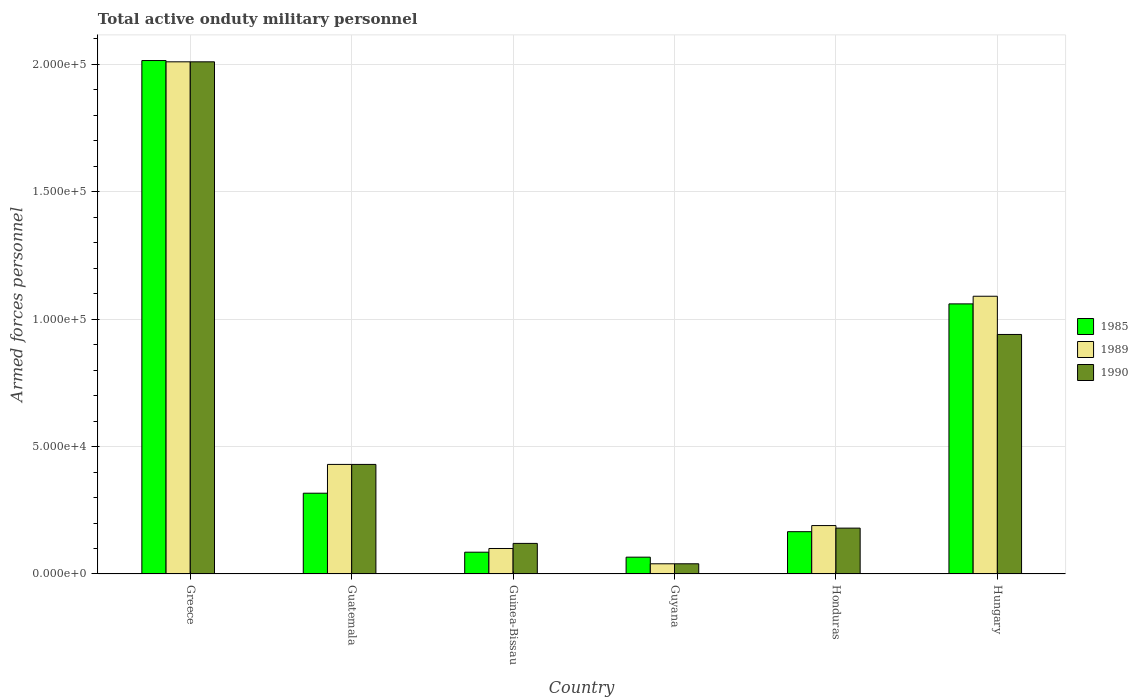How many different coloured bars are there?
Keep it short and to the point. 3. Are the number of bars per tick equal to the number of legend labels?
Offer a terse response. Yes. Are the number of bars on each tick of the X-axis equal?
Offer a very short reply. Yes. How many bars are there on the 6th tick from the left?
Your answer should be very brief. 3. What is the label of the 4th group of bars from the left?
Offer a very short reply. Guyana. In how many cases, is the number of bars for a given country not equal to the number of legend labels?
Make the answer very short. 0. What is the number of armed forces personnel in 1990 in Guatemala?
Ensure brevity in your answer.  4.30e+04. Across all countries, what is the maximum number of armed forces personnel in 1985?
Offer a very short reply. 2.02e+05. Across all countries, what is the minimum number of armed forces personnel in 1985?
Keep it short and to the point. 6600. In which country was the number of armed forces personnel in 1989 maximum?
Provide a short and direct response. Greece. In which country was the number of armed forces personnel in 1989 minimum?
Offer a very short reply. Guyana. What is the total number of armed forces personnel in 1989 in the graph?
Offer a terse response. 3.86e+05. What is the difference between the number of armed forces personnel in 1985 in Guyana and that in Hungary?
Your answer should be very brief. -9.94e+04. What is the difference between the number of armed forces personnel in 1989 in Hungary and the number of armed forces personnel in 1990 in Guinea-Bissau?
Your answer should be very brief. 9.70e+04. What is the average number of armed forces personnel in 1990 per country?
Make the answer very short. 6.20e+04. What is the difference between the number of armed forces personnel of/in 1985 and number of armed forces personnel of/in 1990 in Honduras?
Offer a very short reply. -1400. In how many countries, is the number of armed forces personnel in 1989 greater than 140000?
Your response must be concise. 1. What is the ratio of the number of armed forces personnel in 1989 in Guinea-Bissau to that in Hungary?
Offer a terse response. 0.09. What is the difference between the highest and the second highest number of armed forces personnel in 1990?
Offer a terse response. 1.07e+05. What is the difference between the highest and the lowest number of armed forces personnel in 1989?
Your answer should be compact. 1.97e+05. In how many countries, is the number of armed forces personnel in 1990 greater than the average number of armed forces personnel in 1990 taken over all countries?
Your response must be concise. 2. Is the sum of the number of armed forces personnel in 1989 in Greece and Honduras greater than the maximum number of armed forces personnel in 1990 across all countries?
Ensure brevity in your answer.  Yes. What does the 3rd bar from the left in Guyana represents?
Offer a terse response. 1990. How many bars are there?
Your response must be concise. 18. Are all the bars in the graph horizontal?
Provide a succinct answer. No. How many countries are there in the graph?
Give a very brief answer. 6. Does the graph contain any zero values?
Your response must be concise. No. Does the graph contain grids?
Ensure brevity in your answer.  Yes. Where does the legend appear in the graph?
Give a very brief answer. Center right. How many legend labels are there?
Ensure brevity in your answer.  3. How are the legend labels stacked?
Keep it short and to the point. Vertical. What is the title of the graph?
Your answer should be very brief. Total active onduty military personnel. Does "1997" appear as one of the legend labels in the graph?
Provide a succinct answer. No. What is the label or title of the X-axis?
Give a very brief answer. Country. What is the label or title of the Y-axis?
Offer a very short reply. Armed forces personnel. What is the Armed forces personnel of 1985 in Greece?
Ensure brevity in your answer.  2.02e+05. What is the Armed forces personnel in 1989 in Greece?
Ensure brevity in your answer.  2.01e+05. What is the Armed forces personnel of 1990 in Greece?
Offer a very short reply. 2.01e+05. What is the Armed forces personnel in 1985 in Guatemala?
Your answer should be very brief. 3.17e+04. What is the Armed forces personnel in 1989 in Guatemala?
Provide a succinct answer. 4.30e+04. What is the Armed forces personnel in 1990 in Guatemala?
Offer a terse response. 4.30e+04. What is the Armed forces personnel of 1985 in Guinea-Bissau?
Ensure brevity in your answer.  8550. What is the Armed forces personnel of 1989 in Guinea-Bissau?
Keep it short and to the point. 10000. What is the Armed forces personnel in 1990 in Guinea-Bissau?
Make the answer very short. 1.20e+04. What is the Armed forces personnel of 1985 in Guyana?
Offer a very short reply. 6600. What is the Armed forces personnel in 1989 in Guyana?
Your answer should be compact. 4000. What is the Armed forces personnel of 1990 in Guyana?
Your response must be concise. 4000. What is the Armed forces personnel of 1985 in Honduras?
Your response must be concise. 1.66e+04. What is the Armed forces personnel of 1989 in Honduras?
Make the answer very short. 1.90e+04. What is the Armed forces personnel of 1990 in Honduras?
Give a very brief answer. 1.80e+04. What is the Armed forces personnel in 1985 in Hungary?
Ensure brevity in your answer.  1.06e+05. What is the Armed forces personnel in 1989 in Hungary?
Provide a succinct answer. 1.09e+05. What is the Armed forces personnel of 1990 in Hungary?
Make the answer very short. 9.40e+04. Across all countries, what is the maximum Armed forces personnel in 1985?
Ensure brevity in your answer.  2.02e+05. Across all countries, what is the maximum Armed forces personnel in 1989?
Offer a very short reply. 2.01e+05. Across all countries, what is the maximum Armed forces personnel of 1990?
Offer a terse response. 2.01e+05. Across all countries, what is the minimum Armed forces personnel in 1985?
Provide a short and direct response. 6600. Across all countries, what is the minimum Armed forces personnel of 1989?
Your response must be concise. 4000. Across all countries, what is the minimum Armed forces personnel of 1990?
Provide a succinct answer. 4000. What is the total Armed forces personnel of 1985 in the graph?
Offer a terse response. 3.71e+05. What is the total Armed forces personnel of 1989 in the graph?
Your answer should be very brief. 3.86e+05. What is the total Armed forces personnel in 1990 in the graph?
Give a very brief answer. 3.72e+05. What is the difference between the Armed forces personnel in 1985 in Greece and that in Guatemala?
Provide a succinct answer. 1.70e+05. What is the difference between the Armed forces personnel in 1989 in Greece and that in Guatemala?
Your response must be concise. 1.58e+05. What is the difference between the Armed forces personnel in 1990 in Greece and that in Guatemala?
Your answer should be very brief. 1.58e+05. What is the difference between the Armed forces personnel in 1985 in Greece and that in Guinea-Bissau?
Provide a short and direct response. 1.93e+05. What is the difference between the Armed forces personnel of 1989 in Greece and that in Guinea-Bissau?
Keep it short and to the point. 1.91e+05. What is the difference between the Armed forces personnel of 1990 in Greece and that in Guinea-Bissau?
Your answer should be compact. 1.89e+05. What is the difference between the Armed forces personnel in 1985 in Greece and that in Guyana?
Offer a terse response. 1.95e+05. What is the difference between the Armed forces personnel of 1989 in Greece and that in Guyana?
Make the answer very short. 1.97e+05. What is the difference between the Armed forces personnel of 1990 in Greece and that in Guyana?
Your response must be concise. 1.97e+05. What is the difference between the Armed forces personnel of 1985 in Greece and that in Honduras?
Your answer should be compact. 1.85e+05. What is the difference between the Armed forces personnel in 1989 in Greece and that in Honduras?
Offer a terse response. 1.82e+05. What is the difference between the Armed forces personnel of 1990 in Greece and that in Honduras?
Provide a succinct answer. 1.83e+05. What is the difference between the Armed forces personnel in 1985 in Greece and that in Hungary?
Your answer should be very brief. 9.55e+04. What is the difference between the Armed forces personnel of 1989 in Greece and that in Hungary?
Ensure brevity in your answer.  9.20e+04. What is the difference between the Armed forces personnel in 1990 in Greece and that in Hungary?
Your response must be concise. 1.07e+05. What is the difference between the Armed forces personnel of 1985 in Guatemala and that in Guinea-Bissau?
Provide a short and direct response. 2.32e+04. What is the difference between the Armed forces personnel in 1989 in Guatemala and that in Guinea-Bissau?
Offer a terse response. 3.30e+04. What is the difference between the Armed forces personnel in 1990 in Guatemala and that in Guinea-Bissau?
Make the answer very short. 3.10e+04. What is the difference between the Armed forces personnel of 1985 in Guatemala and that in Guyana?
Offer a terse response. 2.51e+04. What is the difference between the Armed forces personnel of 1989 in Guatemala and that in Guyana?
Keep it short and to the point. 3.90e+04. What is the difference between the Armed forces personnel of 1990 in Guatemala and that in Guyana?
Your answer should be very brief. 3.90e+04. What is the difference between the Armed forces personnel of 1985 in Guatemala and that in Honduras?
Give a very brief answer. 1.51e+04. What is the difference between the Armed forces personnel of 1989 in Guatemala and that in Honduras?
Your answer should be compact. 2.40e+04. What is the difference between the Armed forces personnel of 1990 in Guatemala and that in Honduras?
Your response must be concise. 2.50e+04. What is the difference between the Armed forces personnel of 1985 in Guatemala and that in Hungary?
Provide a succinct answer. -7.43e+04. What is the difference between the Armed forces personnel of 1989 in Guatemala and that in Hungary?
Give a very brief answer. -6.60e+04. What is the difference between the Armed forces personnel in 1990 in Guatemala and that in Hungary?
Your answer should be compact. -5.10e+04. What is the difference between the Armed forces personnel in 1985 in Guinea-Bissau and that in Guyana?
Keep it short and to the point. 1950. What is the difference between the Armed forces personnel in 1989 in Guinea-Bissau and that in Guyana?
Keep it short and to the point. 6000. What is the difference between the Armed forces personnel of 1990 in Guinea-Bissau and that in Guyana?
Keep it short and to the point. 8000. What is the difference between the Armed forces personnel of 1985 in Guinea-Bissau and that in Honduras?
Keep it short and to the point. -8050. What is the difference between the Armed forces personnel in 1989 in Guinea-Bissau and that in Honduras?
Give a very brief answer. -9000. What is the difference between the Armed forces personnel of 1990 in Guinea-Bissau and that in Honduras?
Your response must be concise. -6000. What is the difference between the Armed forces personnel in 1985 in Guinea-Bissau and that in Hungary?
Your answer should be compact. -9.74e+04. What is the difference between the Armed forces personnel in 1989 in Guinea-Bissau and that in Hungary?
Your answer should be compact. -9.90e+04. What is the difference between the Armed forces personnel in 1990 in Guinea-Bissau and that in Hungary?
Keep it short and to the point. -8.20e+04. What is the difference between the Armed forces personnel in 1989 in Guyana and that in Honduras?
Keep it short and to the point. -1.50e+04. What is the difference between the Armed forces personnel of 1990 in Guyana and that in Honduras?
Offer a terse response. -1.40e+04. What is the difference between the Armed forces personnel of 1985 in Guyana and that in Hungary?
Offer a terse response. -9.94e+04. What is the difference between the Armed forces personnel in 1989 in Guyana and that in Hungary?
Offer a very short reply. -1.05e+05. What is the difference between the Armed forces personnel in 1990 in Guyana and that in Hungary?
Your response must be concise. -9.00e+04. What is the difference between the Armed forces personnel in 1985 in Honduras and that in Hungary?
Provide a succinct answer. -8.94e+04. What is the difference between the Armed forces personnel in 1989 in Honduras and that in Hungary?
Your answer should be very brief. -9.00e+04. What is the difference between the Armed forces personnel in 1990 in Honduras and that in Hungary?
Keep it short and to the point. -7.60e+04. What is the difference between the Armed forces personnel of 1985 in Greece and the Armed forces personnel of 1989 in Guatemala?
Offer a terse response. 1.58e+05. What is the difference between the Armed forces personnel of 1985 in Greece and the Armed forces personnel of 1990 in Guatemala?
Keep it short and to the point. 1.58e+05. What is the difference between the Armed forces personnel in 1989 in Greece and the Armed forces personnel in 1990 in Guatemala?
Offer a terse response. 1.58e+05. What is the difference between the Armed forces personnel of 1985 in Greece and the Armed forces personnel of 1989 in Guinea-Bissau?
Your response must be concise. 1.92e+05. What is the difference between the Armed forces personnel of 1985 in Greece and the Armed forces personnel of 1990 in Guinea-Bissau?
Offer a very short reply. 1.90e+05. What is the difference between the Armed forces personnel of 1989 in Greece and the Armed forces personnel of 1990 in Guinea-Bissau?
Offer a terse response. 1.89e+05. What is the difference between the Armed forces personnel of 1985 in Greece and the Armed forces personnel of 1989 in Guyana?
Your response must be concise. 1.98e+05. What is the difference between the Armed forces personnel of 1985 in Greece and the Armed forces personnel of 1990 in Guyana?
Offer a very short reply. 1.98e+05. What is the difference between the Armed forces personnel of 1989 in Greece and the Armed forces personnel of 1990 in Guyana?
Offer a very short reply. 1.97e+05. What is the difference between the Armed forces personnel of 1985 in Greece and the Armed forces personnel of 1989 in Honduras?
Offer a very short reply. 1.82e+05. What is the difference between the Armed forces personnel of 1985 in Greece and the Armed forces personnel of 1990 in Honduras?
Your answer should be very brief. 1.84e+05. What is the difference between the Armed forces personnel in 1989 in Greece and the Armed forces personnel in 1990 in Honduras?
Provide a short and direct response. 1.83e+05. What is the difference between the Armed forces personnel in 1985 in Greece and the Armed forces personnel in 1989 in Hungary?
Ensure brevity in your answer.  9.25e+04. What is the difference between the Armed forces personnel of 1985 in Greece and the Armed forces personnel of 1990 in Hungary?
Provide a short and direct response. 1.08e+05. What is the difference between the Armed forces personnel in 1989 in Greece and the Armed forces personnel in 1990 in Hungary?
Offer a terse response. 1.07e+05. What is the difference between the Armed forces personnel of 1985 in Guatemala and the Armed forces personnel of 1989 in Guinea-Bissau?
Keep it short and to the point. 2.17e+04. What is the difference between the Armed forces personnel in 1985 in Guatemala and the Armed forces personnel in 1990 in Guinea-Bissau?
Make the answer very short. 1.97e+04. What is the difference between the Armed forces personnel in 1989 in Guatemala and the Armed forces personnel in 1990 in Guinea-Bissau?
Provide a succinct answer. 3.10e+04. What is the difference between the Armed forces personnel of 1985 in Guatemala and the Armed forces personnel of 1989 in Guyana?
Provide a succinct answer. 2.77e+04. What is the difference between the Armed forces personnel of 1985 in Guatemala and the Armed forces personnel of 1990 in Guyana?
Make the answer very short. 2.77e+04. What is the difference between the Armed forces personnel in 1989 in Guatemala and the Armed forces personnel in 1990 in Guyana?
Your answer should be compact. 3.90e+04. What is the difference between the Armed forces personnel in 1985 in Guatemala and the Armed forces personnel in 1989 in Honduras?
Provide a succinct answer. 1.27e+04. What is the difference between the Armed forces personnel in 1985 in Guatemala and the Armed forces personnel in 1990 in Honduras?
Provide a succinct answer. 1.37e+04. What is the difference between the Armed forces personnel of 1989 in Guatemala and the Armed forces personnel of 1990 in Honduras?
Offer a terse response. 2.50e+04. What is the difference between the Armed forces personnel of 1985 in Guatemala and the Armed forces personnel of 1989 in Hungary?
Offer a very short reply. -7.73e+04. What is the difference between the Armed forces personnel of 1985 in Guatemala and the Armed forces personnel of 1990 in Hungary?
Provide a short and direct response. -6.23e+04. What is the difference between the Armed forces personnel in 1989 in Guatemala and the Armed forces personnel in 1990 in Hungary?
Offer a terse response. -5.10e+04. What is the difference between the Armed forces personnel of 1985 in Guinea-Bissau and the Armed forces personnel of 1989 in Guyana?
Provide a short and direct response. 4550. What is the difference between the Armed forces personnel of 1985 in Guinea-Bissau and the Armed forces personnel of 1990 in Guyana?
Your response must be concise. 4550. What is the difference between the Armed forces personnel in 1989 in Guinea-Bissau and the Armed forces personnel in 1990 in Guyana?
Your answer should be compact. 6000. What is the difference between the Armed forces personnel in 1985 in Guinea-Bissau and the Armed forces personnel in 1989 in Honduras?
Provide a short and direct response. -1.04e+04. What is the difference between the Armed forces personnel of 1985 in Guinea-Bissau and the Armed forces personnel of 1990 in Honduras?
Your answer should be very brief. -9450. What is the difference between the Armed forces personnel in 1989 in Guinea-Bissau and the Armed forces personnel in 1990 in Honduras?
Your response must be concise. -8000. What is the difference between the Armed forces personnel in 1985 in Guinea-Bissau and the Armed forces personnel in 1989 in Hungary?
Provide a succinct answer. -1.00e+05. What is the difference between the Armed forces personnel in 1985 in Guinea-Bissau and the Armed forces personnel in 1990 in Hungary?
Your answer should be compact. -8.54e+04. What is the difference between the Armed forces personnel of 1989 in Guinea-Bissau and the Armed forces personnel of 1990 in Hungary?
Keep it short and to the point. -8.40e+04. What is the difference between the Armed forces personnel in 1985 in Guyana and the Armed forces personnel in 1989 in Honduras?
Make the answer very short. -1.24e+04. What is the difference between the Armed forces personnel of 1985 in Guyana and the Armed forces personnel of 1990 in Honduras?
Ensure brevity in your answer.  -1.14e+04. What is the difference between the Armed forces personnel of 1989 in Guyana and the Armed forces personnel of 1990 in Honduras?
Your answer should be compact. -1.40e+04. What is the difference between the Armed forces personnel in 1985 in Guyana and the Armed forces personnel in 1989 in Hungary?
Provide a short and direct response. -1.02e+05. What is the difference between the Armed forces personnel of 1985 in Guyana and the Armed forces personnel of 1990 in Hungary?
Your answer should be very brief. -8.74e+04. What is the difference between the Armed forces personnel of 1989 in Guyana and the Armed forces personnel of 1990 in Hungary?
Make the answer very short. -9.00e+04. What is the difference between the Armed forces personnel in 1985 in Honduras and the Armed forces personnel in 1989 in Hungary?
Ensure brevity in your answer.  -9.24e+04. What is the difference between the Armed forces personnel in 1985 in Honduras and the Armed forces personnel in 1990 in Hungary?
Ensure brevity in your answer.  -7.74e+04. What is the difference between the Armed forces personnel of 1989 in Honduras and the Armed forces personnel of 1990 in Hungary?
Offer a very short reply. -7.50e+04. What is the average Armed forces personnel of 1985 per country?
Offer a terse response. 6.18e+04. What is the average Armed forces personnel in 1989 per country?
Your response must be concise. 6.43e+04. What is the average Armed forces personnel in 1990 per country?
Make the answer very short. 6.20e+04. What is the difference between the Armed forces personnel of 1985 and Armed forces personnel of 1989 in Greece?
Give a very brief answer. 500. What is the difference between the Armed forces personnel in 1985 and Armed forces personnel in 1990 in Greece?
Your response must be concise. 500. What is the difference between the Armed forces personnel in 1989 and Armed forces personnel in 1990 in Greece?
Keep it short and to the point. 0. What is the difference between the Armed forces personnel of 1985 and Armed forces personnel of 1989 in Guatemala?
Your response must be concise. -1.13e+04. What is the difference between the Armed forces personnel in 1985 and Armed forces personnel in 1990 in Guatemala?
Give a very brief answer. -1.13e+04. What is the difference between the Armed forces personnel in 1989 and Armed forces personnel in 1990 in Guatemala?
Ensure brevity in your answer.  0. What is the difference between the Armed forces personnel in 1985 and Armed forces personnel in 1989 in Guinea-Bissau?
Ensure brevity in your answer.  -1450. What is the difference between the Armed forces personnel of 1985 and Armed forces personnel of 1990 in Guinea-Bissau?
Keep it short and to the point. -3450. What is the difference between the Armed forces personnel of 1989 and Armed forces personnel of 1990 in Guinea-Bissau?
Keep it short and to the point. -2000. What is the difference between the Armed forces personnel in 1985 and Armed forces personnel in 1989 in Guyana?
Keep it short and to the point. 2600. What is the difference between the Armed forces personnel in 1985 and Armed forces personnel in 1990 in Guyana?
Ensure brevity in your answer.  2600. What is the difference between the Armed forces personnel in 1989 and Armed forces personnel in 1990 in Guyana?
Make the answer very short. 0. What is the difference between the Armed forces personnel in 1985 and Armed forces personnel in 1989 in Honduras?
Make the answer very short. -2400. What is the difference between the Armed forces personnel in 1985 and Armed forces personnel in 1990 in Honduras?
Make the answer very short. -1400. What is the difference between the Armed forces personnel in 1989 and Armed forces personnel in 1990 in Honduras?
Provide a short and direct response. 1000. What is the difference between the Armed forces personnel in 1985 and Armed forces personnel in 1989 in Hungary?
Your response must be concise. -3000. What is the difference between the Armed forces personnel of 1985 and Armed forces personnel of 1990 in Hungary?
Make the answer very short. 1.20e+04. What is the difference between the Armed forces personnel of 1989 and Armed forces personnel of 1990 in Hungary?
Your answer should be very brief. 1.50e+04. What is the ratio of the Armed forces personnel in 1985 in Greece to that in Guatemala?
Provide a short and direct response. 6.36. What is the ratio of the Armed forces personnel in 1989 in Greece to that in Guatemala?
Ensure brevity in your answer.  4.67. What is the ratio of the Armed forces personnel in 1990 in Greece to that in Guatemala?
Your answer should be very brief. 4.67. What is the ratio of the Armed forces personnel in 1985 in Greece to that in Guinea-Bissau?
Make the answer very short. 23.57. What is the ratio of the Armed forces personnel in 1989 in Greece to that in Guinea-Bissau?
Keep it short and to the point. 20.1. What is the ratio of the Armed forces personnel of 1990 in Greece to that in Guinea-Bissau?
Give a very brief answer. 16.75. What is the ratio of the Armed forces personnel of 1985 in Greece to that in Guyana?
Your answer should be compact. 30.53. What is the ratio of the Armed forces personnel of 1989 in Greece to that in Guyana?
Your answer should be compact. 50.25. What is the ratio of the Armed forces personnel of 1990 in Greece to that in Guyana?
Give a very brief answer. 50.25. What is the ratio of the Armed forces personnel of 1985 in Greece to that in Honduras?
Offer a very short reply. 12.14. What is the ratio of the Armed forces personnel in 1989 in Greece to that in Honduras?
Offer a very short reply. 10.58. What is the ratio of the Armed forces personnel in 1990 in Greece to that in Honduras?
Offer a terse response. 11.17. What is the ratio of the Armed forces personnel of 1985 in Greece to that in Hungary?
Give a very brief answer. 1.9. What is the ratio of the Armed forces personnel of 1989 in Greece to that in Hungary?
Offer a terse response. 1.84. What is the ratio of the Armed forces personnel of 1990 in Greece to that in Hungary?
Offer a very short reply. 2.14. What is the ratio of the Armed forces personnel in 1985 in Guatemala to that in Guinea-Bissau?
Ensure brevity in your answer.  3.71. What is the ratio of the Armed forces personnel of 1990 in Guatemala to that in Guinea-Bissau?
Your response must be concise. 3.58. What is the ratio of the Armed forces personnel in 1985 in Guatemala to that in Guyana?
Your response must be concise. 4.8. What is the ratio of the Armed forces personnel of 1989 in Guatemala to that in Guyana?
Ensure brevity in your answer.  10.75. What is the ratio of the Armed forces personnel of 1990 in Guatemala to that in Guyana?
Keep it short and to the point. 10.75. What is the ratio of the Armed forces personnel in 1985 in Guatemala to that in Honduras?
Your answer should be very brief. 1.91. What is the ratio of the Armed forces personnel in 1989 in Guatemala to that in Honduras?
Ensure brevity in your answer.  2.26. What is the ratio of the Armed forces personnel of 1990 in Guatemala to that in Honduras?
Give a very brief answer. 2.39. What is the ratio of the Armed forces personnel in 1985 in Guatemala to that in Hungary?
Offer a terse response. 0.3. What is the ratio of the Armed forces personnel of 1989 in Guatemala to that in Hungary?
Keep it short and to the point. 0.39. What is the ratio of the Armed forces personnel of 1990 in Guatemala to that in Hungary?
Give a very brief answer. 0.46. What is the ratio of the Armed forces personnel of 1985 in Guinea-Bissau to that in Guyana?
Your answer should be compact. 1.3. What is the ratio of the Armed forces personnel of 1990 in Guinea-Bissau to that in Guyana?
Make the answer very short. 3. What is the ratio of the Armed forces personnel in 1985 in Guinea-Bissau to that in Honduras?
Make the answer very short. 0.52. What is the ratio of the Armed forces personnel of 1989 in Guinea-Bissau to that in Honduras?
Ensure brevity in your answer.  0.53. What is the ratio of the Armed forces personnel in 1990 in Guinea-Bissau to that in Honduras?
Provide a succinct answer. 0.67. What is the ratio of the Armed forces personnel in 1985 in Guinea-Bissau to that in Hungary?
Keep it short and to the point. 0.08. What is the ratio of the Armed forces personnel in 1989 in Guinea-Bissau to that in Hungary?
Make the answer very short. 0.09. What is the ratio of the Armed forces personnel of 1990 in Guinea-Bissau to that in Hungary?
Provide a succinct answer. 0.13. What is the ratio of the Armed forces personnel of 1985 in Guyana to that in Honduras?
Give a very brief answer. 0.4. What is the ratio of the Armed forces personnel in 1989 in Guyana to that in Honduras?
Provide a short and direct response. 0.21. What is the ratio of the Armed forces personnel in 1990 in Guyana to that in Honduras?
Your answer should be very brief. 0.22. What is the ratio of the Armed forces personnel of 1985 in Guyana to that in Hungary?
Offer a very short reply. 0.06. What is the ratio of the Armed forces personnel of 1989 in Guyana to that in Hungary?
Your response must be concise. 0.04. What is the ratio of the Armed forces personnel of 1990 in Guyana to that in Hungary?
Offer a very short reply. 0.04. What is the ratio of the Armed forces personnel in 1985 in Honduras to that in Hungary?
Your answer should be very brief. 0.16. What is the ratio of the Armed forces personnel of 1989 in Honduras to that in Hungary?
Your answer should be compact. 0.17. What is the ratio of the Armed forces personnel of 1990 in Honduras to that in Hungary?
Your response must be concise. 0.19. What is the difference between the highest and the second highest Armed forces personnel in 1985?
Offer a very short reply. 9.55e+04. What is the difference between the highest and the second highest Armed forces personnel of 1989?
Your response must be concise. 9.20e+04. What is the difference between the highest and the second highest Armed forces personnel of 1990?
Provide a short and direct response. 1.07e+05. What is the difference between the highest and the lowest Armed forces personnel of 1985?
Give a very brief answer. 1.95e+05. What is the difference between the highest and the lowest Armed forces personnel of 1989?
Your answer should be very brief. 1.97e+05. What is the difference between the highest and the lowest Armed forces personnel in 1990?
Your answer should be compact. 1.97e+05. 